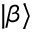<formula> <loc_0><loc_0><loc_500><loc_500>| \beta \rangle</formula> 